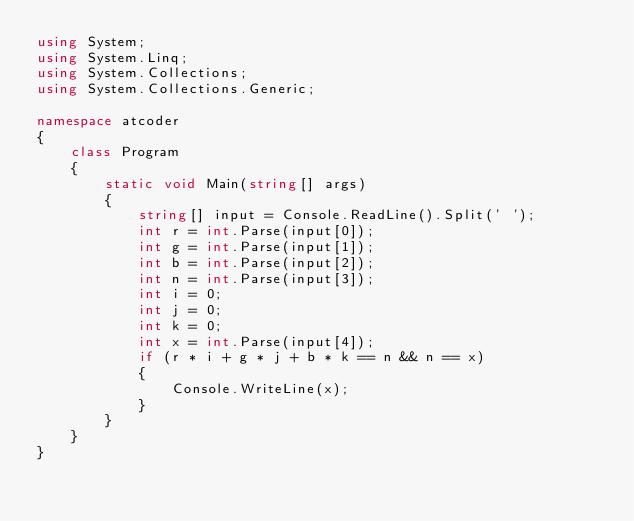<code> <loc_0><loc_0><loc_500><loc_500><_C#_>using System;
using System.Linq;
using System.Collections;
using System.Collections.Generic;

namespace atcoder
{
    class Program
    {
        static void Main(string[] args)
        {
            string[] input = Console.ReadLine().Split(' ');
            int r = int.Parse(input[0]);
            int g = int.Parse(input[1]);
            int b = int.Parse(input[2]);
            int n = int.Parse(input[3]);
            int i = 0;
            int j = 0;
            int k = 0;
            int x = int.Parse(input[4]);
            if (r * i + g * j + b * k == n && n == x)
            {
                Console.WriteLine(x);
            }
        }
    }
}</code> 